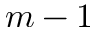Convert formula to latex. <formula><loc_0><loc_0><loc_500><loc_500>m - 1</formula> 